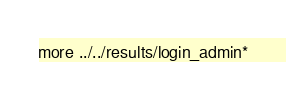<code> <loc_0><loc_0><loc_500><loc_500><_Bash_>more ../../results/login_admin*
</code> 